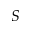<formula> <loc_0><loc_0><loc_500><loc_500>S</formula> 